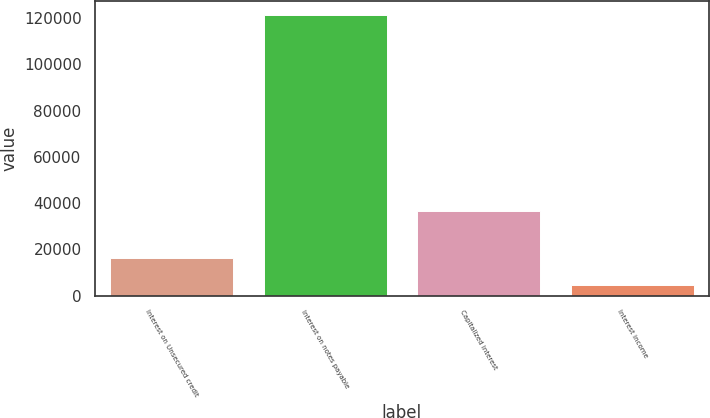Convert chart. <chart><loc_0><loc_0><loc_500><loc_500><bar_chart><fcel>Interest on Unsecured credit<fcel>Interest on notes payable<fcel>Capitalized interest<fcel>Interest income<nl><fcel>16359.9<fcel>121335<fcel>36510<fcel>4696<nl></chart> 